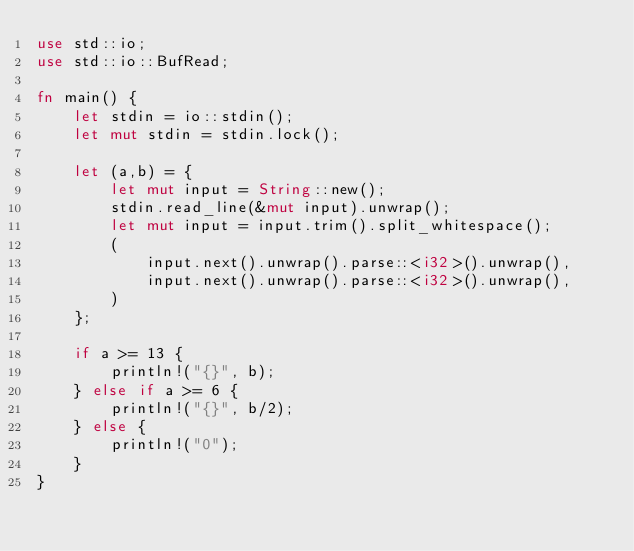Convert code to text. <code><loc_0><loc_0><loc_500><loc_500><_Rust_>use std::io;
use std::io::BufRead;

fn main() {
    let stdin = io::stdin();
    let mut stdin = stdin.lock();

    let (a,b) = {
        let mut input = String::new();
        stdin.read_line(&mut input).unwrap();
        let mut input = input.trim().split_whitespace();
        (
            input.next().unwrap().parse::<i32>().unwrap(),
            input.next().unwrap().parse::<i32>().unwrap(),
        )
    };

    if a >= 13 {
        println!("{}", b);
    } else if a >= 6 {
        println!("{}", b/2);
    } else {
        println!("0");
    }
}
</code> 